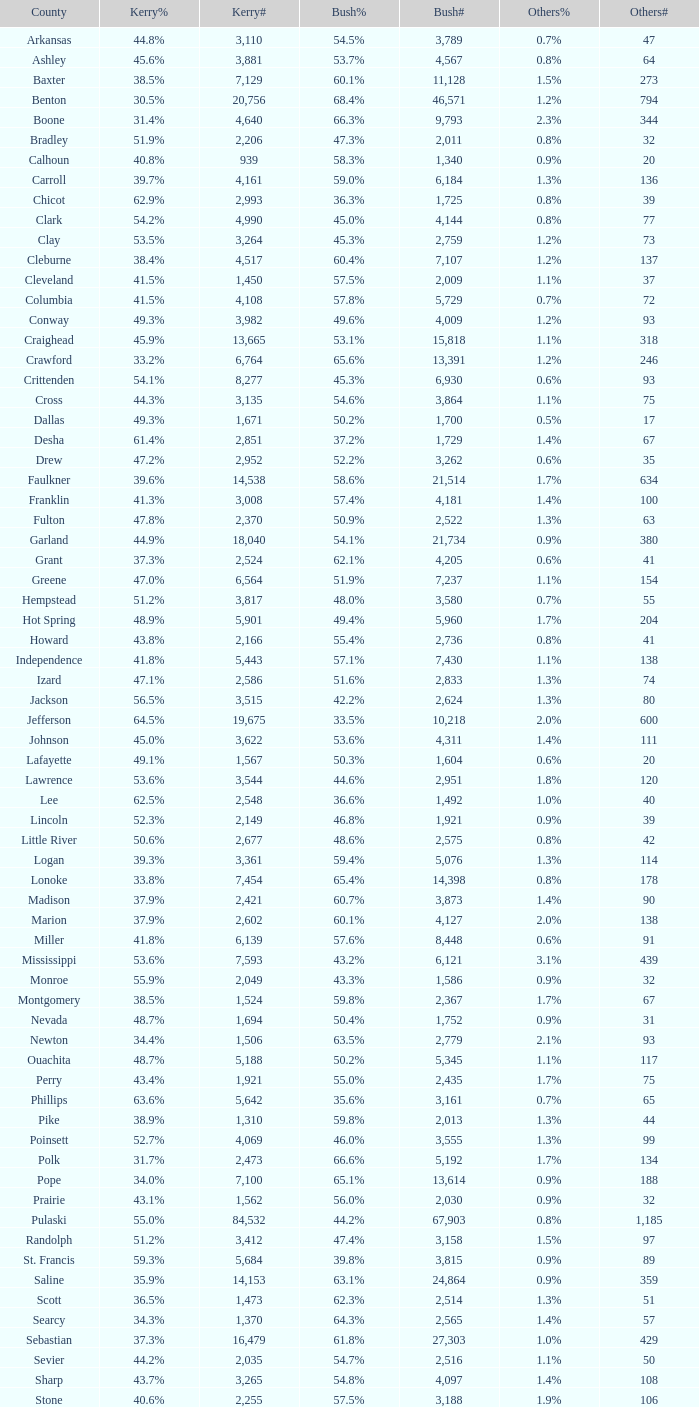What is the least kerry#, when others# is "106", and when bush# is lesser than 3,188? None. 